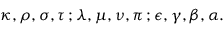<formula> <loc_0><loc_0><loc_500><loc_500>\kappa , \rho , \sigma , \tau \, ; \lambda , \mu , \nu , \pi \, ; \epsilon , \gamma , \beta , \alpha .</formula> 